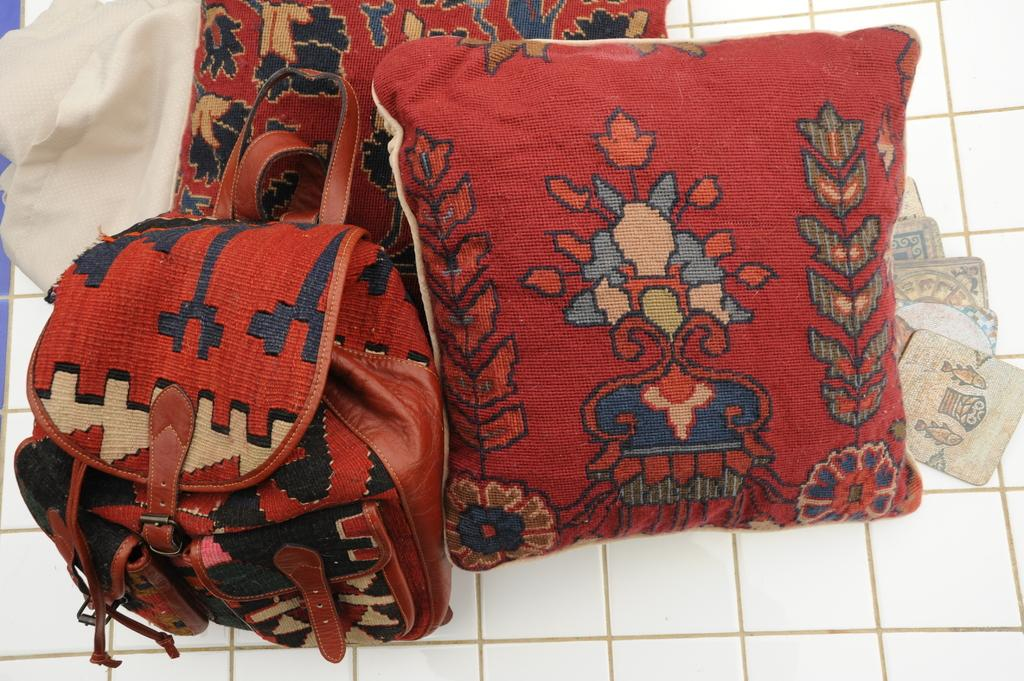What is located in the foreground of the image? In the foreground of the image, there is a red bag, two cushions, a white cloth, and square-shaped objects on a white surface. Can you describe the red bag in the image? The red bag is in the foreground of the image. What color are the cushions in the image? The cushions in the image are also in the foreground and are not described as having a specific color. What is the material of the white cloth in the image? The material of the white cloth in the image is not specified in the provided facts. What shape are the objects on the white surface in the image? The objects on the white surface in the foreground of the image are square-shaped. How many chess pieces are on the white surface in the image? There is no mention of chess pieces in the provided facts. --- Facts: 1. There is a person in the image. 2. The person is wearing a hat. 3. The person is holding a book. 4. The person is standing in front of a bookshelf. Absurd Topics: parrot, piano, Conversation: Who or what is in the image? In the image, there is a person. What is the person wearing in the image? The person in the image is wearing a hat. What is the person holding in the image? The person in the image is holding a book. What is the person standing in front of in the image? The person in the image is standing in front of a bookshelf. Reasoning: Let's think step by step in order to produce the conversation. We start by identifying the main subject of the image, which is the person. Next, we describe specific features of the person, such as the hat. Then, we observe the actions of the person, noting that they are holding a book. Finally, we describe the setting where the person is located, which is in front of a bookshelf. Absurd Question/Answer: What type of parrot can be seen sitting on the person's shoulder in the image? There is no parrot present in the image. --- Facts: 1. There is a dog in the image. 2. The dog is sitting on a chair. 3. The dog is wearing a red bow tie. 4. The chair is located next to a table. Absurd Topics: cat, Conversation: What type of animal is in the image? In the image, there is a dog. What is the dog doing in the image? The dog in the image is sitting on a chair. What is the dog wearing in the image? The dog in the image is wearing a red bow tie. What is located next to the chair in the image? The chair in the image is located next to a table. 